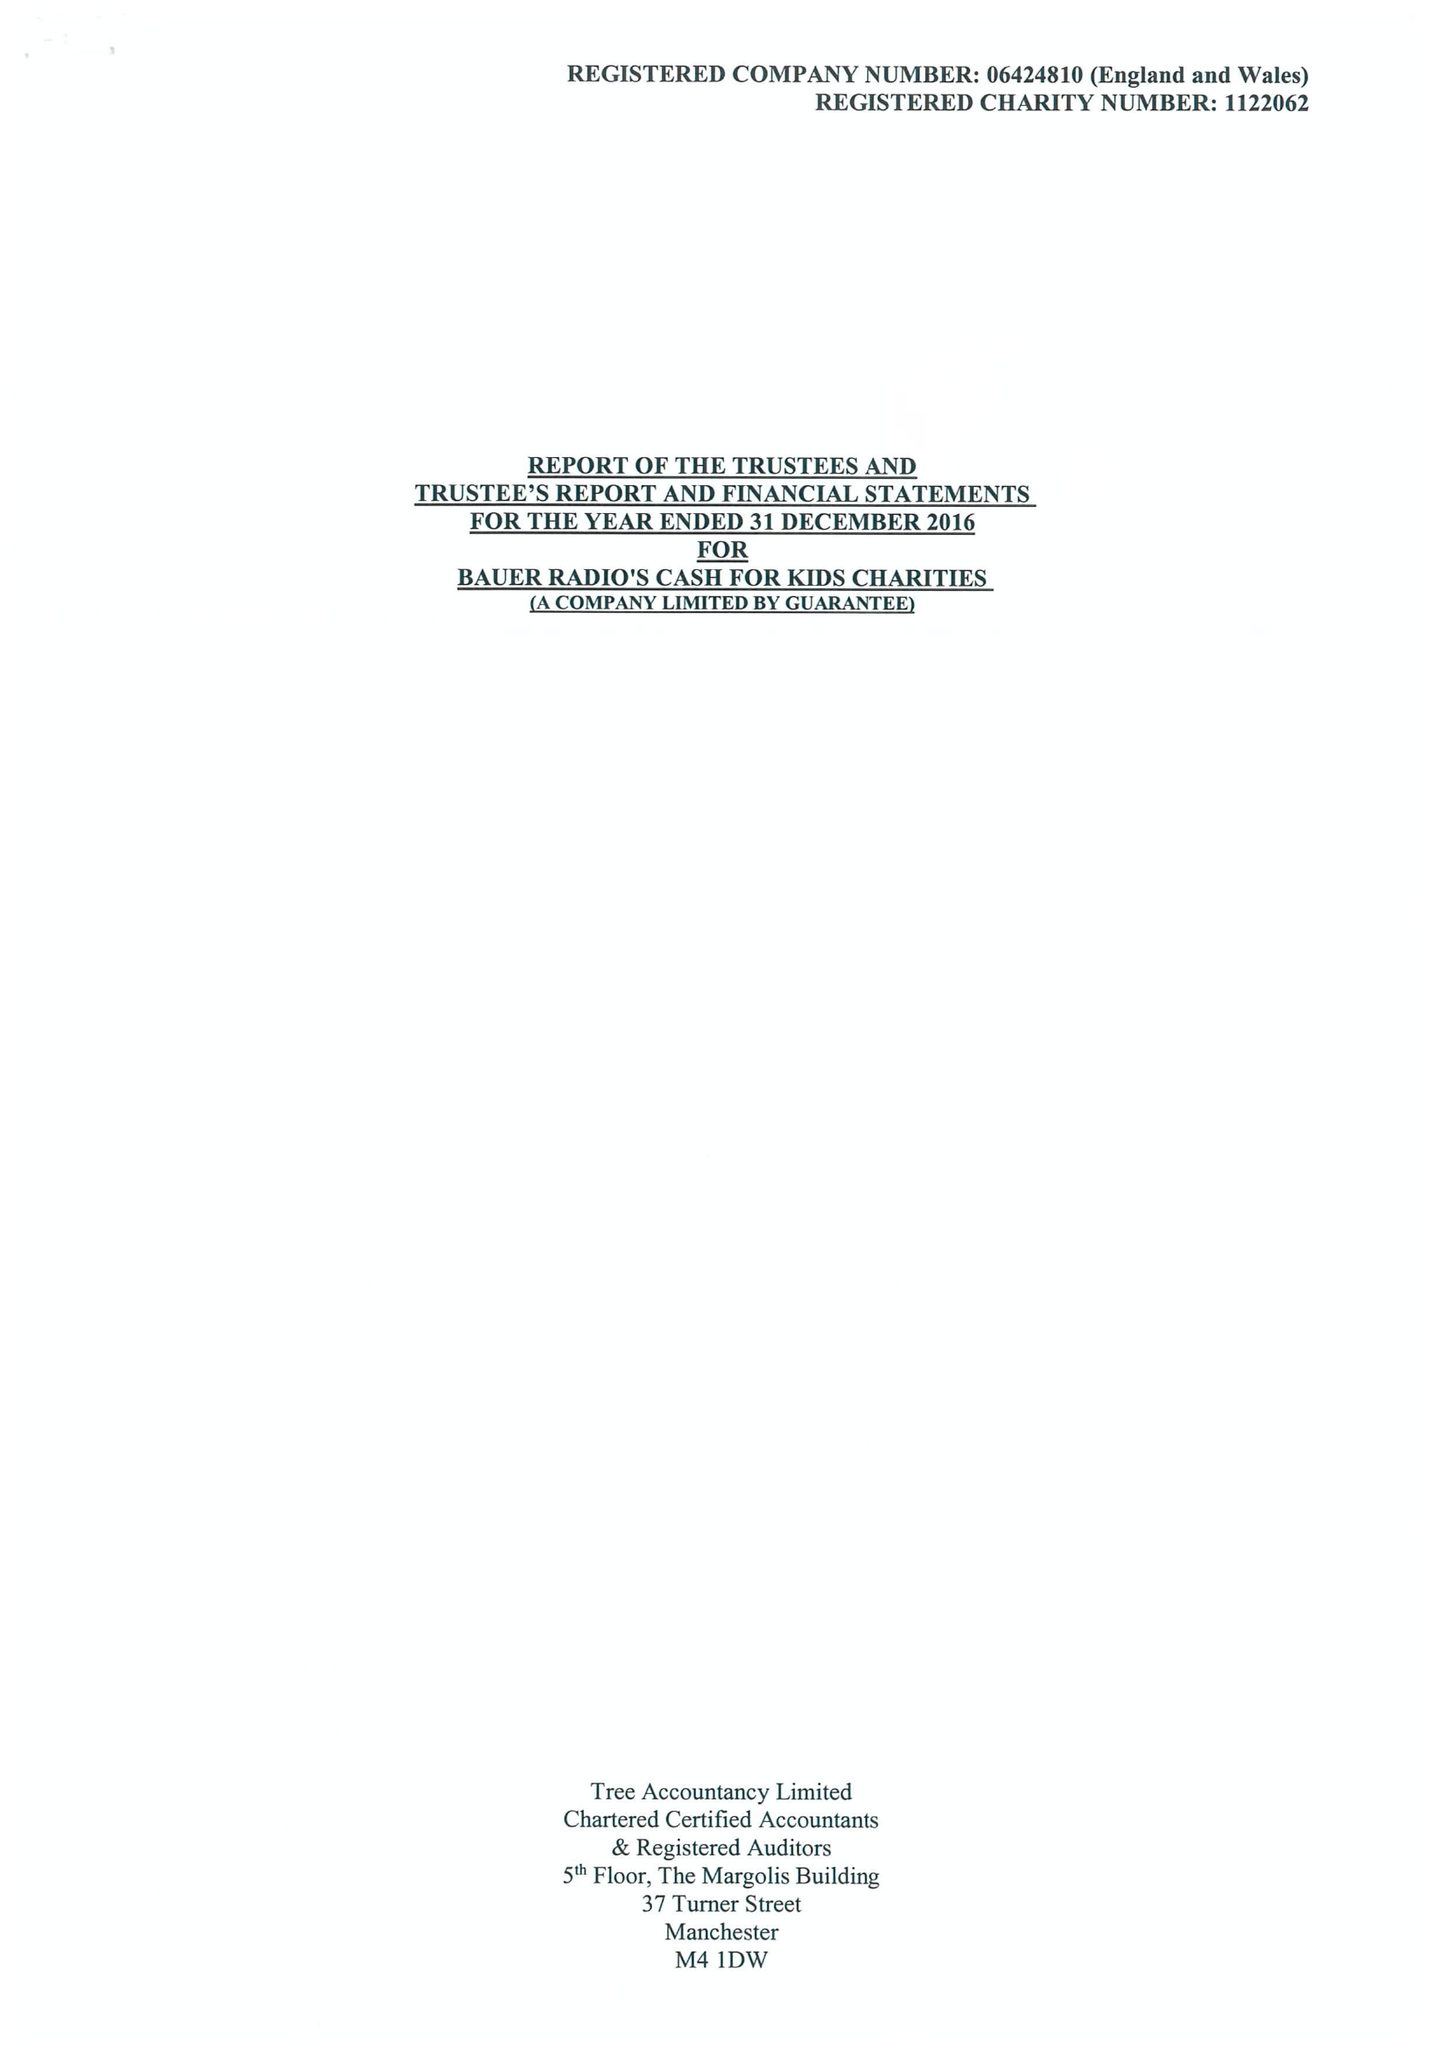What is the value for the address__street_line?
Answer the question using a single word or phrase. None 